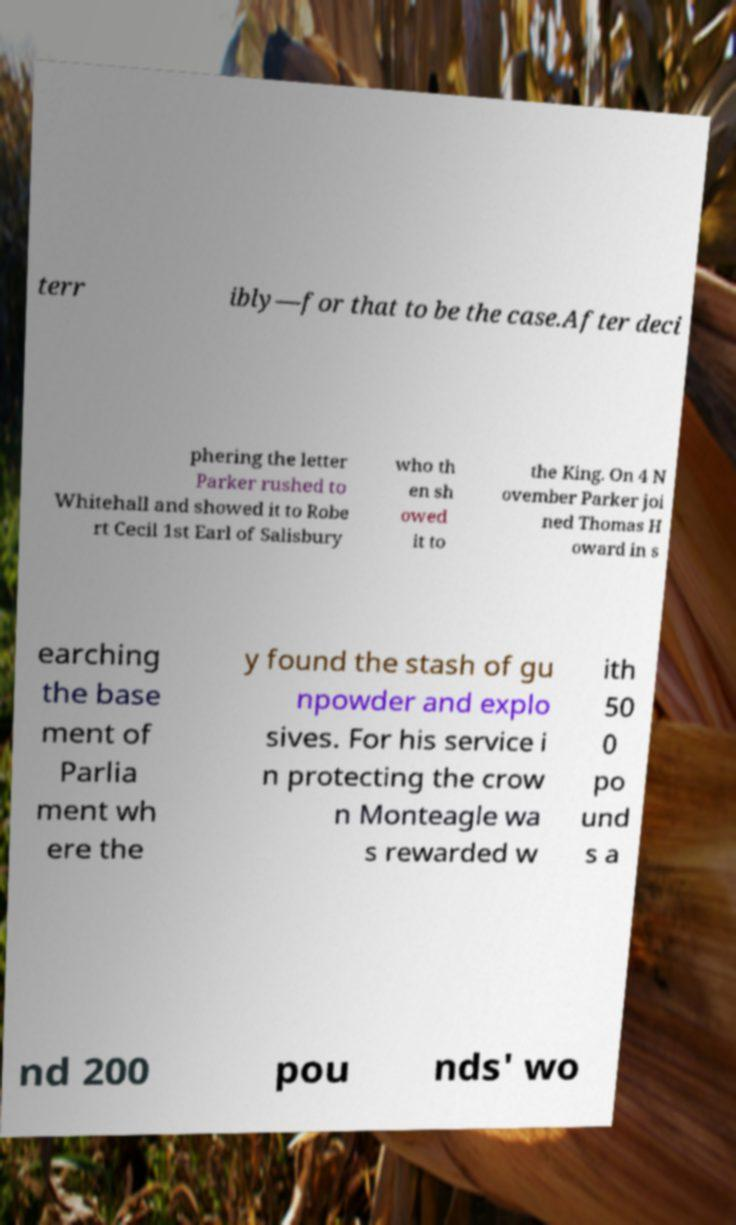What messages or text are displayed in this image? I need them in a readable, typed format. terr ibly—for that to be the case.After deci phering the letter Parker rushed to Whitehall and showed it to Robe rt Cecil 1st Earl of Salisbury who th en sh owed it to the King. On 4 N ovember Parker joi ned Thomas H oward in s earching the base ment of Parlia ment wh ere the y found the stash of gu npowder and explo sives. For his service i n protecting the crow n Monteagle wa s rewarded w ith 50 0 po und s a nd 200 pou nds' wo 